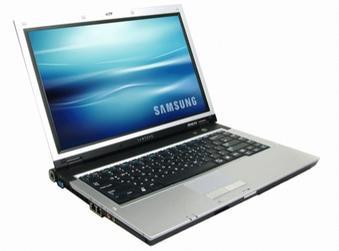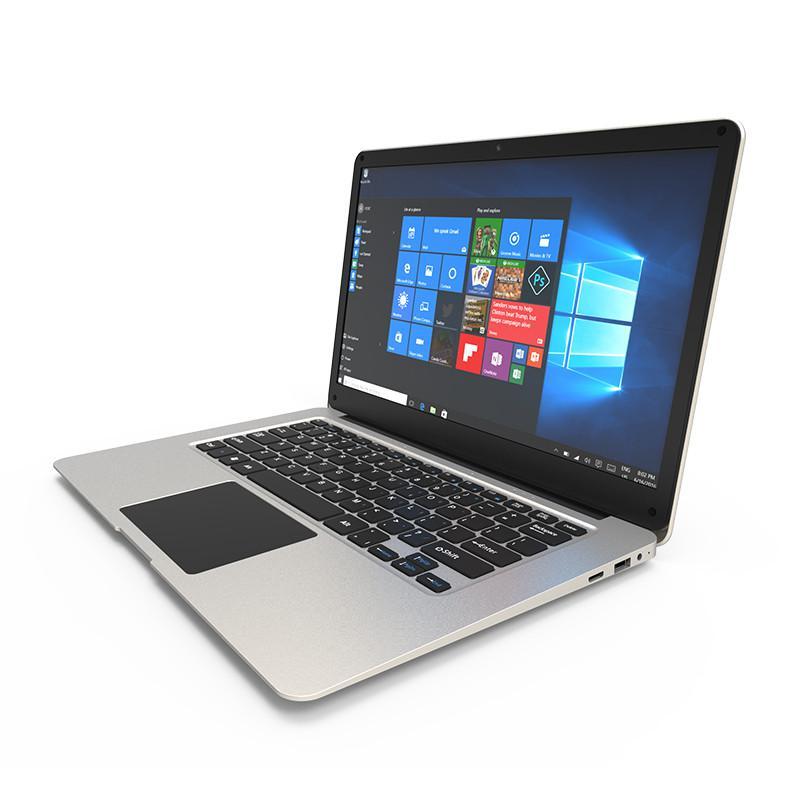The first image is the image on the left, the second image is the image on the right. Assess this claim about the two images: "the laptop in the image on the right is facing the bottom right". Correct or not? Answer yes or no. No. The first image is the image on the left, the second image is the image on the right. Evaluate the accuracy of this statement regarding the images: "An image of a single laptop features a screen saver consisting of horizontal waves of blue tones.". Is it true? Answer yes or no. Yes. 